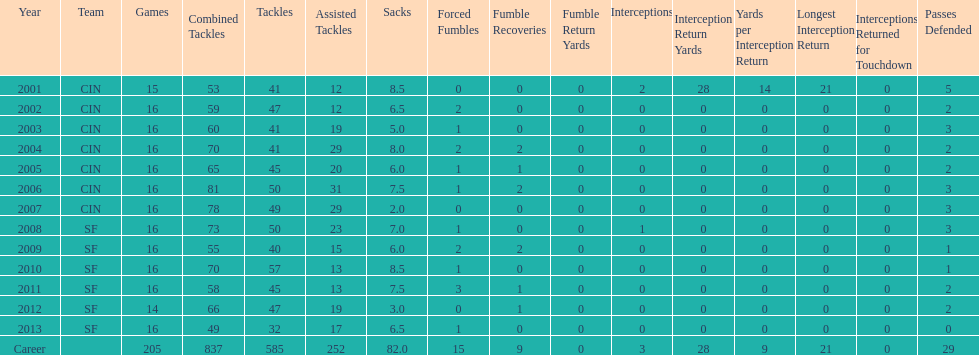Can you give me this table as a dict? {'header': ['Year', 'Team', 'Games', 'Combined Tackles', 'Tackles', 'Assisted Tackles', 'Sacks', 'Forced Fumbles', 'Fumble Recoveries', 'Fumble Return Yards', 'Interceptions', 'Interception Return Yards', 'Yards per Interception Return', 'Longest Interception Return', 'Interceptions Returned for Touchdown', 'Passes Defended'], 'rows': [['2001', 'CIN', '15', '53', '41', '12', '8.5', '0', '0', '0', '2', '28', '14', '21', '0', '5'], ['2002', 'CIN', '16', '59', '47', '12', '6.5', '2', '0', '0', '0', '0', '0', '0', '0', '2'], ['2003', 'CIN', '16', '60', '41', '19', '5.0', '1', '0', '0', '0', '0', '0', '0', '0', '3'], ['2004', 'CIN', '16', '70', '41', '29', '8.0', '2', '2', '0', '0', '0', '0', '0', '0', '2'], ['2005', 'CIN', '16', '65', '45', '20', '6.0', '1', '1', '0', '0', '0', '0', '0', '0', '2'], ['2006', 'CIN', '16', '81', '50', '31', '7.5', '1', '2', '0', '0', '0', '0', '0', '0', '3'], ['2007', 'CIN', '16', '78', '49', '29', '2.0', '0', '0', '0', '0', '0', '0', '0', '0', '3'], ['2008', 'SF', '16', '73', '50', '23', '7.0', '1', '0', '0', '1', '0', '0', '0', '0', '3'], ['2009', 'SF', '16', '55', '40', '15', '6.0', '2', '2', '0', '0', '0', '0', '0', '0', '1'], ['2010', 'SF', '16', '70', '57', '13', '8.5', '1', '0', '0', '0', '0', '0', '0', '0', '1'], ['2011', 'SF', '16', '58', '45', '13', '7.5', '3', '1', '0', '0', '0', '0', '0', '0', '2'], ['2012', 'SF', '14', '66', '47', '19', '3.0', '0', '1', '0', '0', '0', '0', '0', '0', '2'], ['2013', 'SF', '16', '49', '32', '17', '6.5', '1', '0', '0', '0', '0', '0', '0', '0', '0'], ['Career', '', '205', '837', '585', '252', '82.0', '15', '9', '0', '3', '28', '9', '21', '0', '29']]} What is the total number of sacks smith has made? 82.0. 